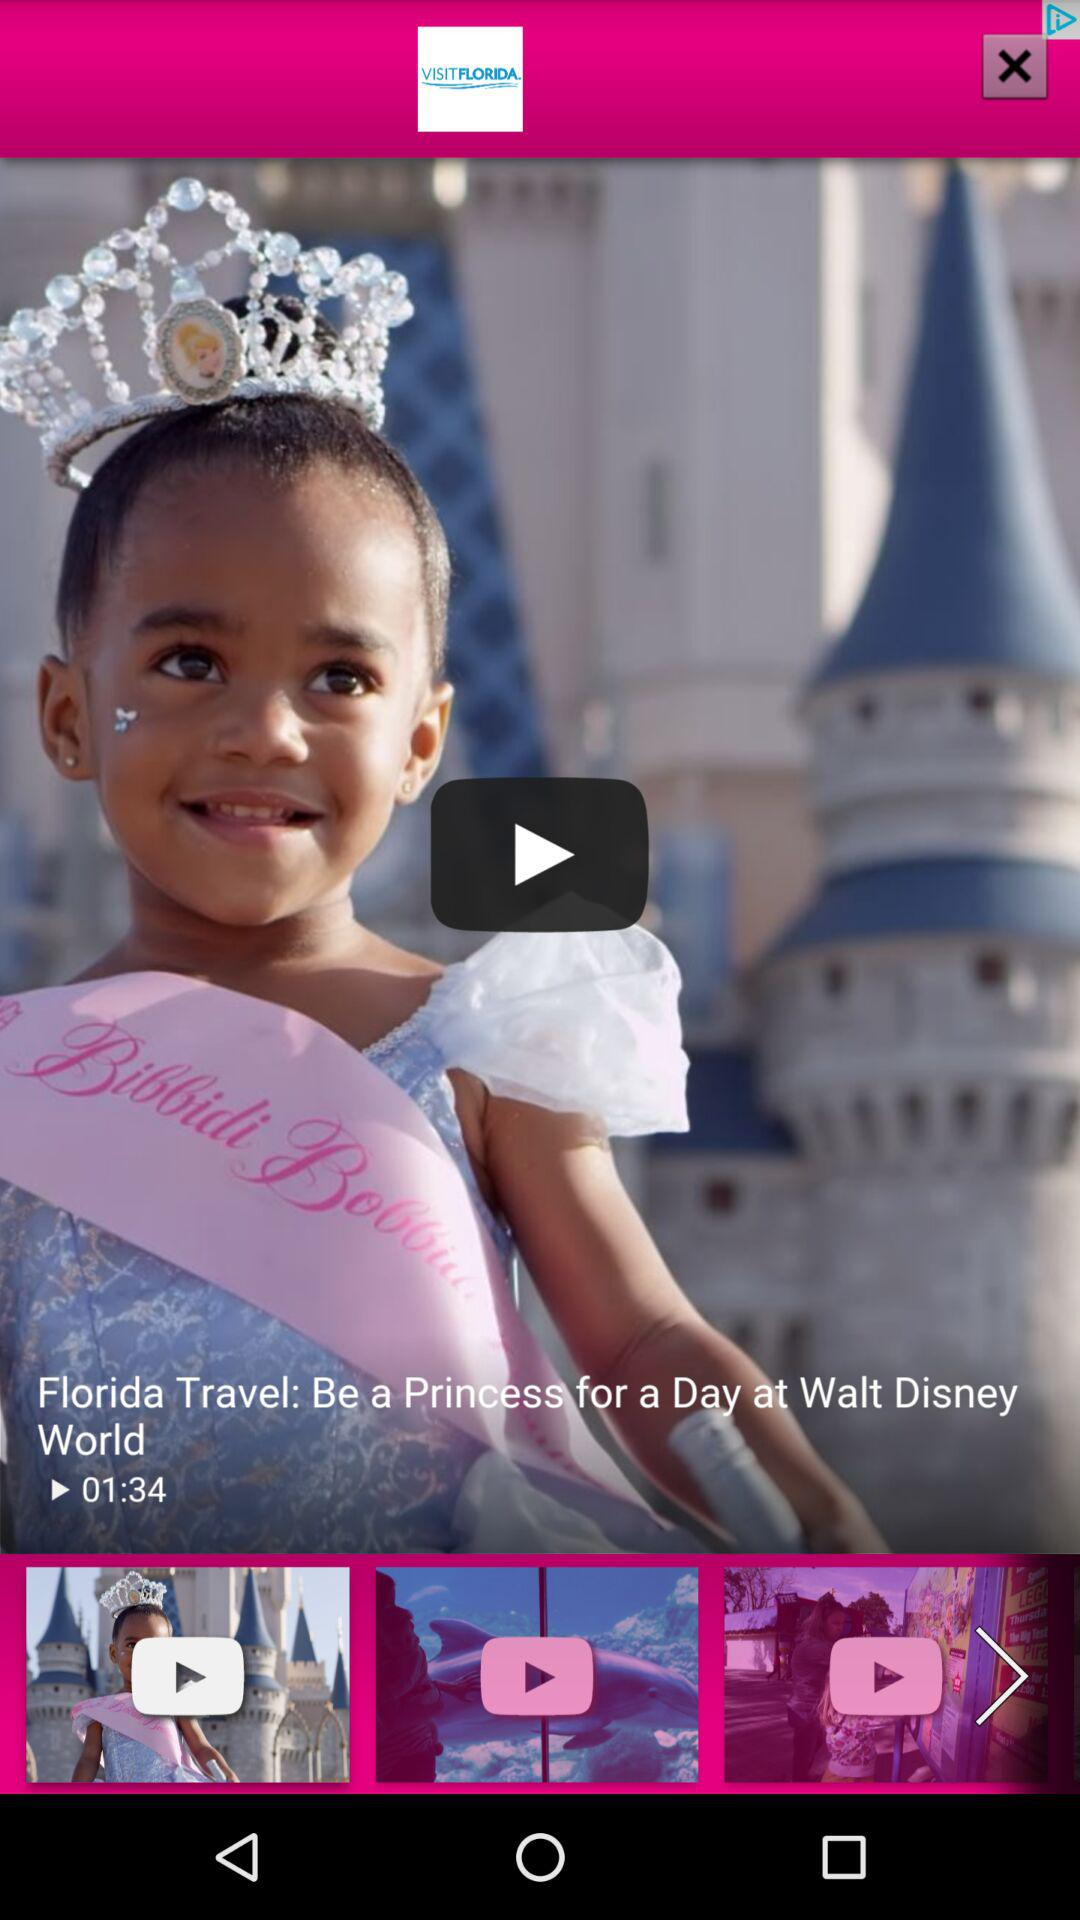What is the duration of "Florida Travel: Be a Princess for a Day at Walt Disney World" video? The duration of the video is 01:34. 